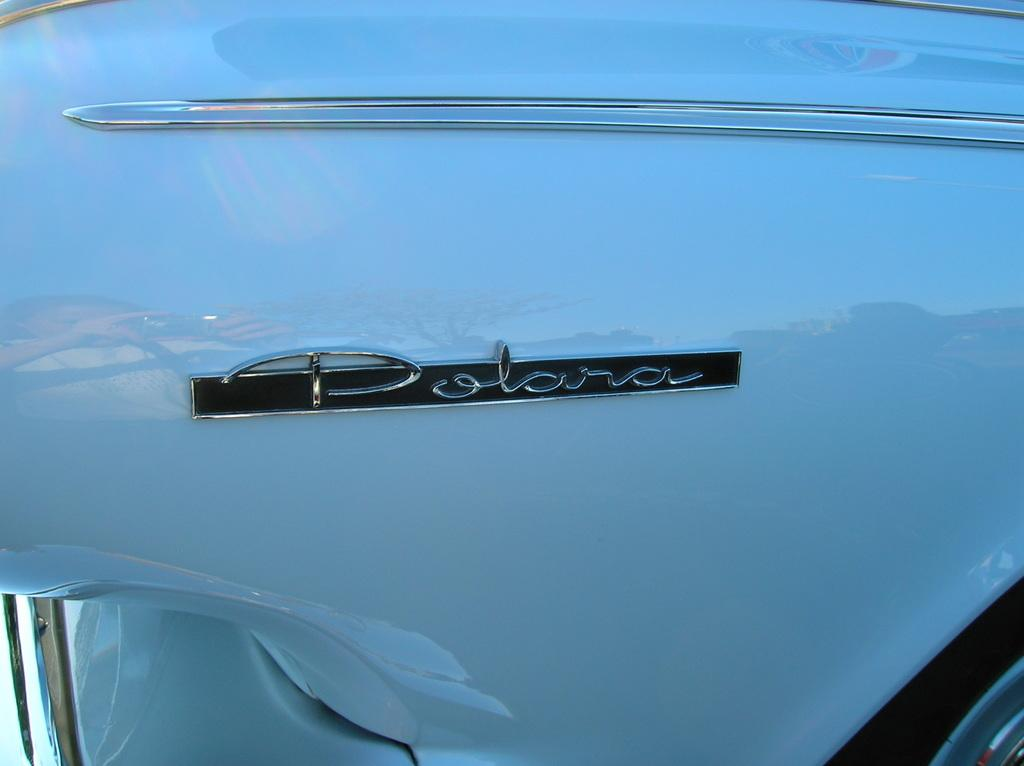What type of car is in the image? The car in the image is a Polara. What color is the car? The car is white in color. Can you see a pencil in the image? There is no pencil present in the image. What type of tiger is sitting on the hood of the car in the image? There is no tiger present in the image; it only features a white Polara car. 